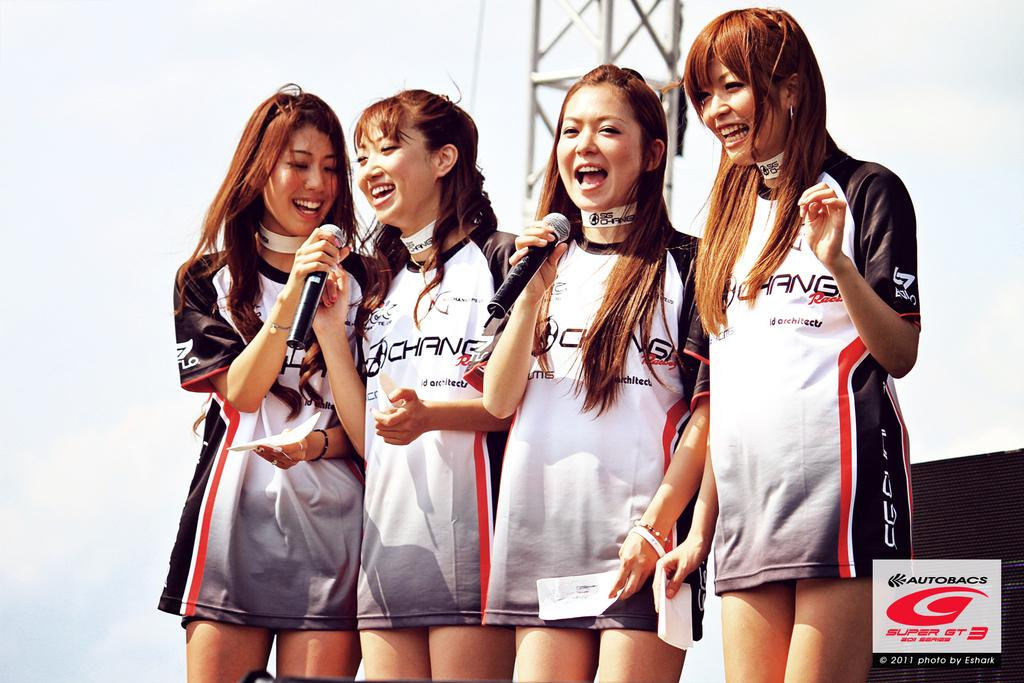Provide a one-sentence caption for the provided image. A group of 4 girls wearing Autobacs branded T-shirts. 